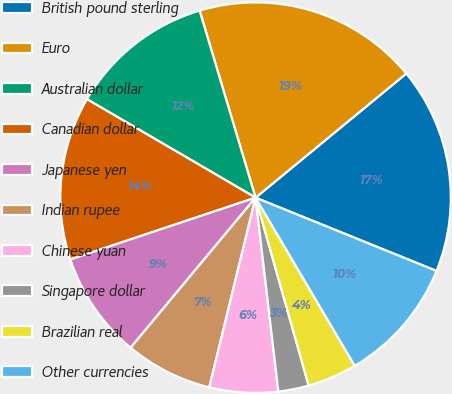Convert chart. <chart><loc_0><loc_0><loc_500><loc_500><pie_chart><fcel>British pound sterling<fcel>Euro<fcel>Australian dollar<fcel>Canadian dollar<fcel>Japanese yen<fcel>Indian rupee<fcel>Chinese yuan<fcel>Singapore dollar<fcel>Brazilian real<fcel>Other currencies<nl><fcel>17.09%<fcel>18.66%<fcel>11.96%<fcel>13.54%<fcel>8.82%<fcel>7.24%<fcel>5.67%<fcel>2.52%<fcel>4.1%<fcel>10.39%<nl></chart> 